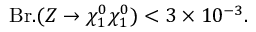Convert formula to latex. <formula><loc_0><loc_0><loc_500><loc_500>B r . ( Z \rightarrow \chi _ { 1 } ^ { 0 } \chi _ { 1 } ^ { 0 } ) < 3 \times 1 0 ^ { - 3 } .</formula> 